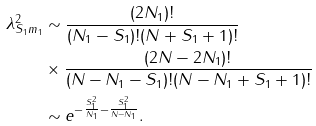<formula> <loc_0><loc_0><loc_500><loc_500>\lambda _ { S _ { 1 } m _ { 1 } } ^ { 2 } & \sim \frac { ( 2 N _ { 1 } ) ! } { ( N _ { 1 } - S _ { 1 } ) ! ( N + S _ { 1 } + 1 ) ! } \\ & \times \frac { ( 2 N - 2 N _ { 1 } ) ! } { ( N - N _ { 1 } - S _ { 1 } ) ! ( N - N _ { 1 } + S _ { 1 } + 1 ) ! } \\ & \sim e ^ { - \frac { S _ { 1 } ^ { 2 } } { N _ { 1 } } - \frac { S _ { 1 } ^ { 2 } } { N - N _ { 1 } } } . \\</formula> 